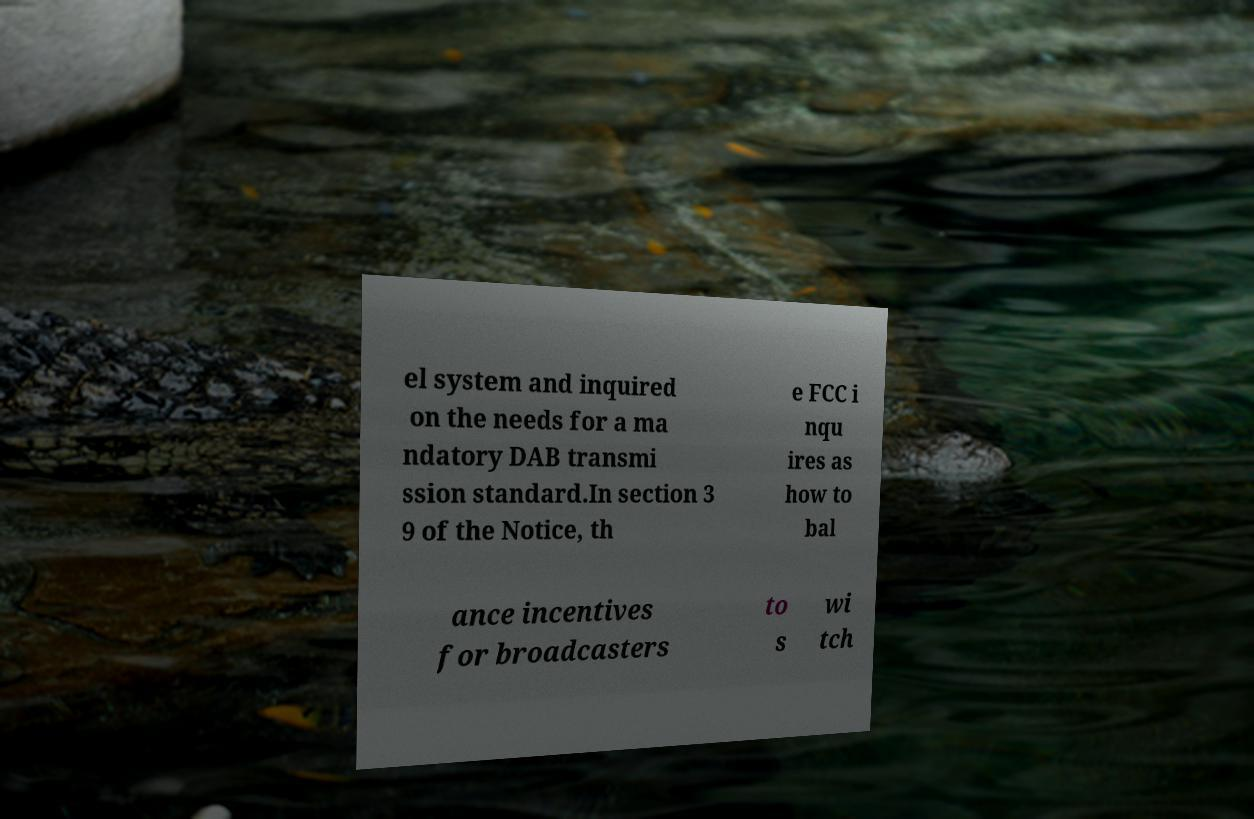Please identify and transcribe the text found in this image. el system and inquired on the needs for a ma ndatory DAB transmi ssion standard.In section 3 9 of the Notice, th e FCC i nqu ires as how to bal ance incentives for broadcasters to s wi tch 